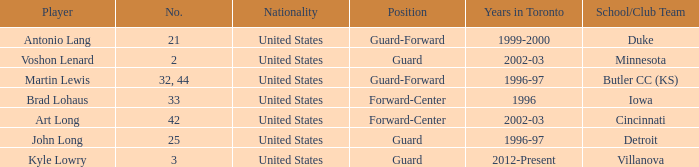What position does the player who played for butler cc (ks) play? Guard-Forward. Can you parse all the data within this table? {'header': ['Player', 'No.', 'Nationality', 'Position', 'Years in Toronto', 'School/Club Team'], 'rows': [['Antonio Lang', '21', 'United States', 'Guard-Forward', '1999-2000', 'Duke'], ['Voshon Lenard', '2', 'United States', 'Guard', '2002-03', 'Minnesota'], ['Martin Lewis', '32, 44', 'United States', 'Guard-Forward', '1996-97', 'Butler CC (KS)'], ['Brad Lohaus', '33', 'United States', 'Forward-Center', '1996', 'Iowa'], ['Art Long', '42', 'United States', 'Forward-Center', '2002-03', 'Cincinnati'], ['John Long', '25', 'United States', 'Guard', '1996-97', 'Detroit'], ['Kyle Lowry', '3', 'United States', 'Guard', '2012-Present', 'Villanova']]} 